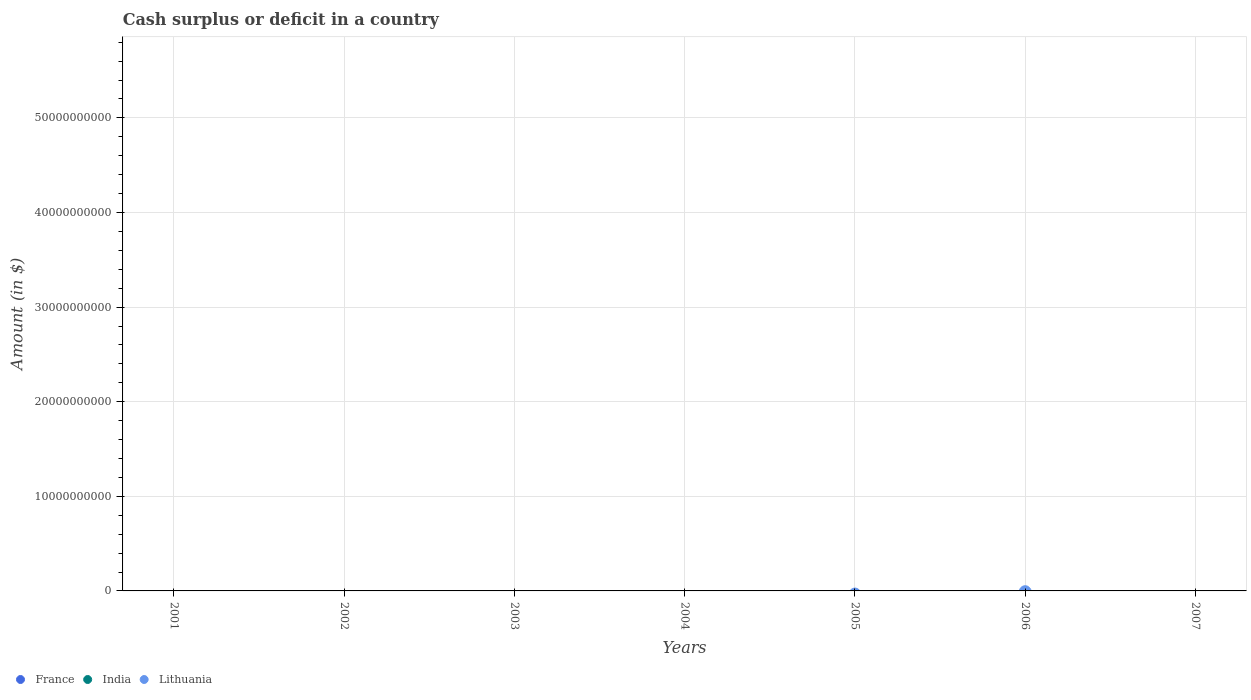How many different coloured dotlines are there?
Your answer should be compact. 0. Is the number of dotlines equal to the number of legend labels?
Provide a succinct answer. No. What is the total amount of cash surplus or deficit in France in the graph?
Offer a very short reply. 0. What is the difference between the amount of cash surplus or deficit in India in 2006 and the amount of cash surplus or deficit in France in 2007?
Your answer should be compact. 0. In how many years, is the amount of cash surplus or deficit in India greater than 26000000000 $?
Give a very brief answer. 0. In how many years, is the amount of cash surplus or deficit in France greater than the average amount of cash surplus or deficit in France taken over all years?
Offer a very short reply. 0. Is it the case that in every year, the sum of the amount of cash surplus or deficit in Lithuania and amount of cash surplus or deficit in India  is greater than the amount of cash surplus or deficit in France?
Ensure brevity in your answer.  No. Does the amount of cash surplus or deficit in Lithuania monotonically increase over the years?
Your response must be concise. No. Is the amount of cash surplus or deficit in France strictly less than the amount of cash surplus or deficit in Lithuania over the years?
Your response must be concise. Yes. How many years are there in the graph?
Keep it short and to the point. 7. Does the graph contain any zero values?
Give a very brief answer. Yes. Where does the legend appear in the graph?
Offer a very short reply. Bottom left. How are the legend labels stacked?
Your response must be concise. Horizontal. What is the title of the graph?
Give a very brief answer. Cash surplus or deficit in a country. Does "Burkina Faso" appear as one of the legend labels in the graph?
Provide a short and direct response. No. What is the label or title of the Y-axis?
Your answer should be compact. Amount (in $). What is the Amount (in $) of France in 2001?
Keep it short and to the point. 0. What is the Amount (in $) of France in 2002?
Your response must be concise. 0. What is the Amount (in $) in France in 2003?
Your answer should be compact. 0. What is the Amount (in $) of India in 2003?
Your response must be concise. 0. What is the Amount (in $) in Lithuania in 2003?
Your response must be concise. 0. What is the Amount (in $) in France in 2005?
Your answer should be compact. 0. What is the Amount (in $) in Lithuania in 2005?
Your answer should be compact. 0. What is the Amount (in $) of India in 2006?
Your response must be concise. 0. What is the Amount (in $) in France in 2007?
Make the answer very short. 0. What is the Amount (in $) in India in 2007?
Ensure brevity in your answer.  0. What is the total Amount (in $) in India in the graph?
Offer a very short reply. 0. What is the total Amount (in $) of Lithuania in the graph?
Your response must be concise. 0. What is the average Amount (in $) of France per year?
Give a very brief answer. 0. 